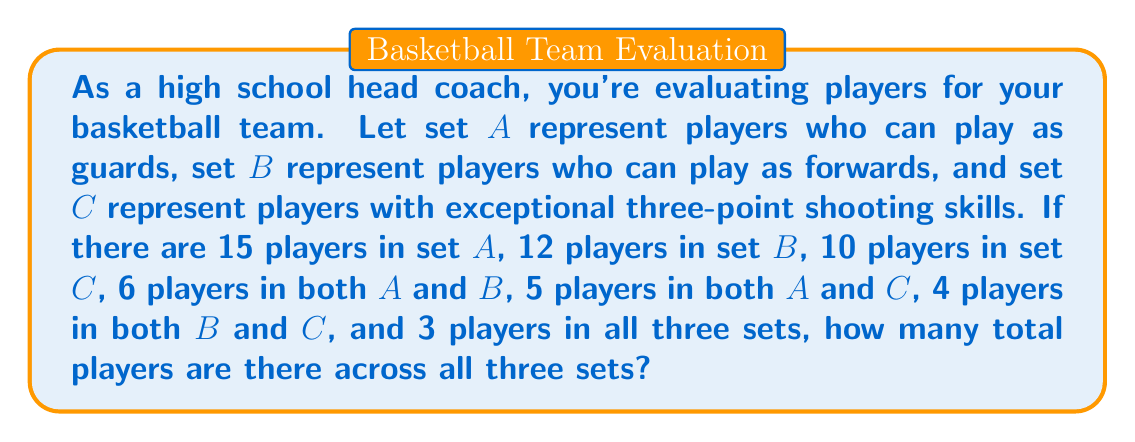Help me with this question. To solve this problem, we'll use the principle of inclusion-exclusion for three sets. Let's break it down step-by-step:

1) First, let's recall the formula for the number of elements in the union of three sets:

   $$|A \cup B \cup C| = |A| + |B| + |C| - |A \cap B| - |A \cap C| - |B \cap C| + |A \cap B \cap C|$$

2) Now, let's plug in the values we know:
   - $|A| = 15$ (players who can play as guards)
   - $|B| = 12$ (players who can play as forwards)
   - $|C| = 10$ (players with exceptional three-point shooting skills)
   - $|A \cap B| = 6$ (players who can play as both guards and forwards)
   - $|A \cap C| = 5$ (guards with exceptional three-point shooting)
   - $|B \cap C| = 4$ (forwards with exceptional three-point shooting)
   - $|A \cap B \cap C| = 3$ (players who can play as guards and forwards and have exceptional three-point shooting)

3) Let's substitute these values into our formula:

   $$|A \cup B \cup C| = 15 + 12 + 10 - 6 - 5 - 4 + 3$$

4) Now we can simply calculate:

   $$|A \cup B \cup C| = 37 - 15 + 3 = 25$$

Therefore, there are 25 total players across all three sets.
Answer: 25 players 